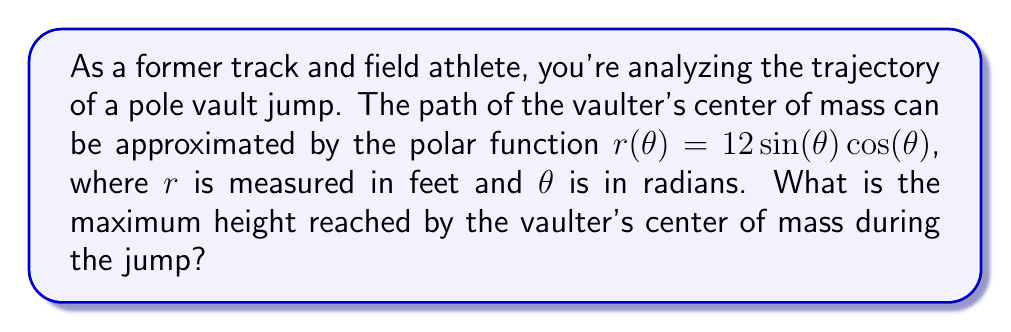Can you solve this math problem? To find the maximum height reached by the vaulter's center of mass, we need to follow these steps:

1) The given polar function is $r(\theta) = 12 \sin(\theta) \cos(\theta)$. This can be rewritten as $r(\theta) = 6 \sin(2\theta)$ using the trigonometric identity $2\sin\theta\cos\theta = \sin(2\theta)$.

2) To convert from polar to Cartesian coordinates, we use:
   $x = r\cos\theta = 6 \sin(2\theta)\cos\theta$
   $y = r\sin\theta = 6 \sin(2\theta)\sin\theta$

3) The height is represented by the y-coordinate. To find the maximum height, we need to find the maximum value of y.

4) Using the identity $\sin(2\theta) = 2\sin\theta\cos\theta$, we can rewrite y as:
   $y = 6 (2\sin\theta\cos\theta)\sin\theta = 12 \sin^2\theta\cos\theta$

5) To find the maximum, we differentiate y with respect to $\theta$ and set it to zero:
   $$\frac{dy}{d\theta} = 12(2\sin\theta\cos^2\theta - \sin^3\theta) = 0$$

6) This equation is satisfied when $\sin\theta = 0$ (which gives y = 0, not the maximum) or when:
   $2\cos^2\theta - \sin^2\theta = 0$

7) Using the identity $\sin^2\theta + \cos^2\theta = 1$, we can solve this:
   $2\cos^2\theta - (1-\cos^2\theta) = 0$
   $3\cos^2\theta - 1 = 0$
   $\cos^2\theta = \frac{1}{3}$
   $\cos\theta = \frac{1}{\sqrt{3}}$ (we take the positive value as we're interested in the upper half of the trajectory)

8) Therefore, $\sin\theta = \sqrt{1-\cos^2\theta} = \sqrt{1-\frac{1}{3}} = \frac{\sqrt{2}}{\sqrt{3}}$

9) Substituting these values back into the equation for y:
   $y_{max} = 12 (\frac{\sqrt{2}}{\sqrt{3}})^2 \cdot \frac{1}{\sqrt{3}} = 12 \cdot \frac{2}{3} \cdot \frac{1}{\sqrt{3}} = 8\sqrt{3}$ feet
Answer: The maximum height reached by the vaulter's center of mass is $8\sqrt{3}$ feet, or approximately 13.86 feet. 